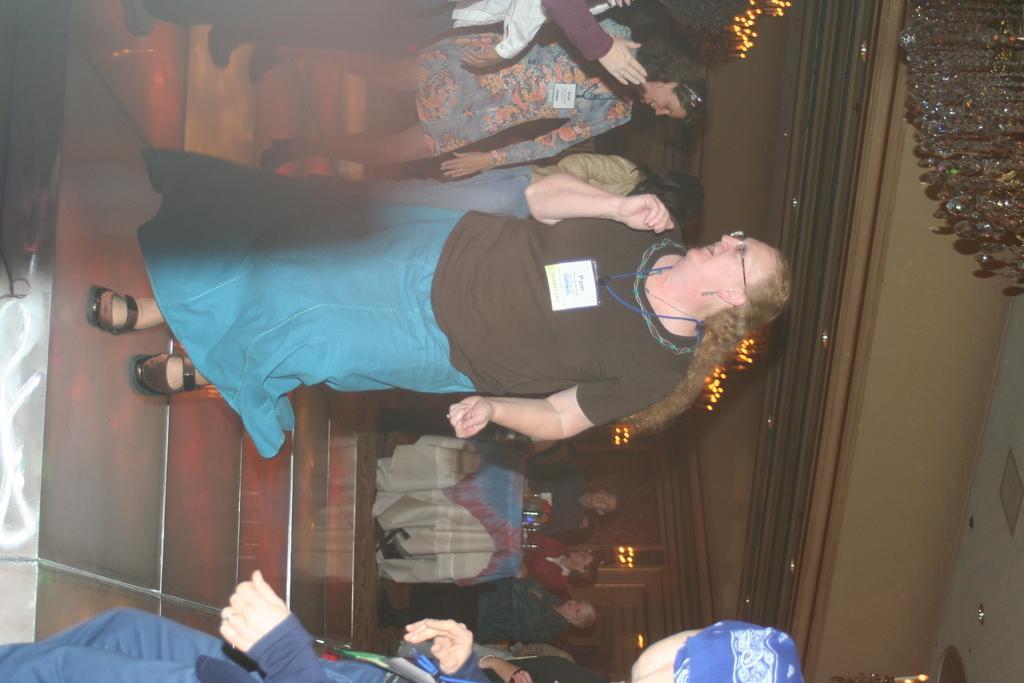How would you summarize this image in a sentence or two? In this picture there are people on the left side of the image and there are other people those who are sitting around the table on the right side of the image and there are decorative lights at the top side of the image. 